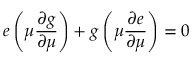<formula> <loc_0><loc_0><loc_500><loc_500>e \left ( \mu { \frac { \partial g } { \partial \mu } } \right ) + g \left ( \mu { \frac { \partial e } { \partial \mu } } \right ) = 0</formula> 